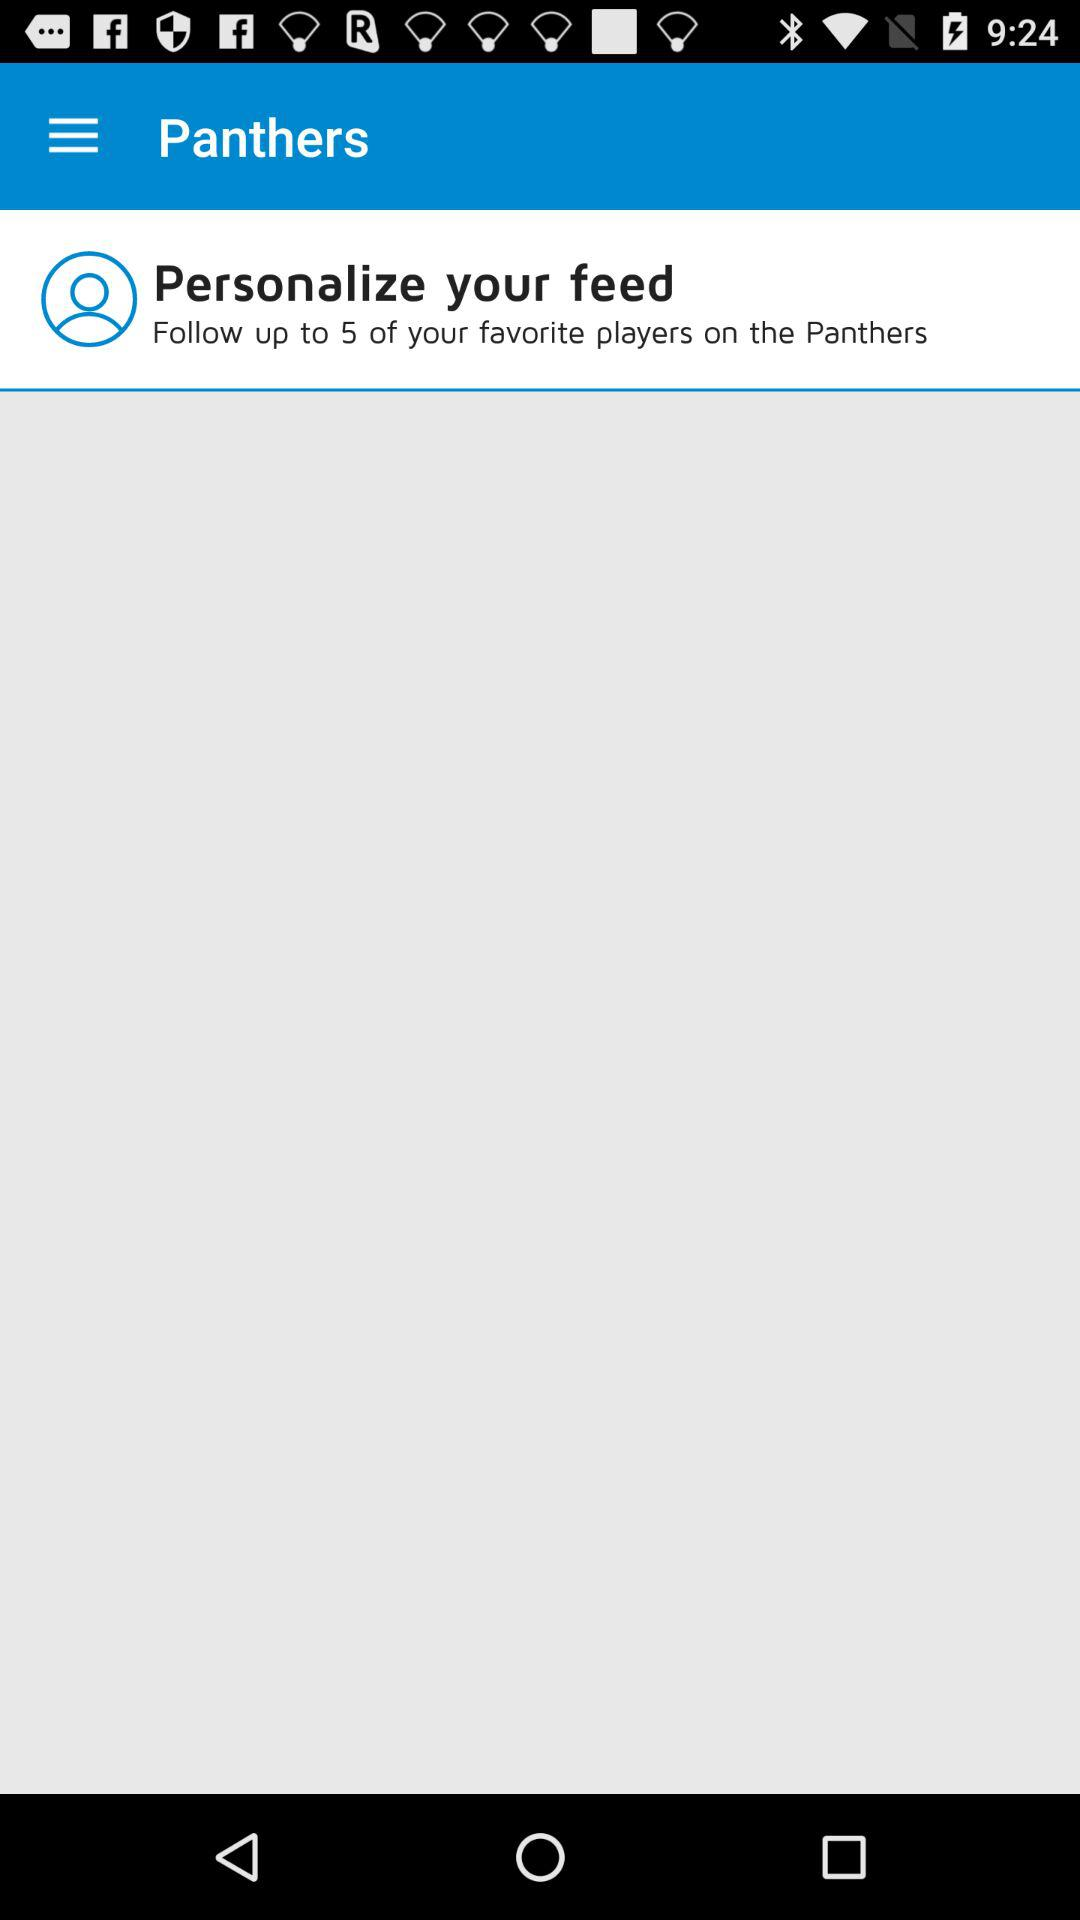How many favorite players can be followed? There are up to 5 players that can be followed. 